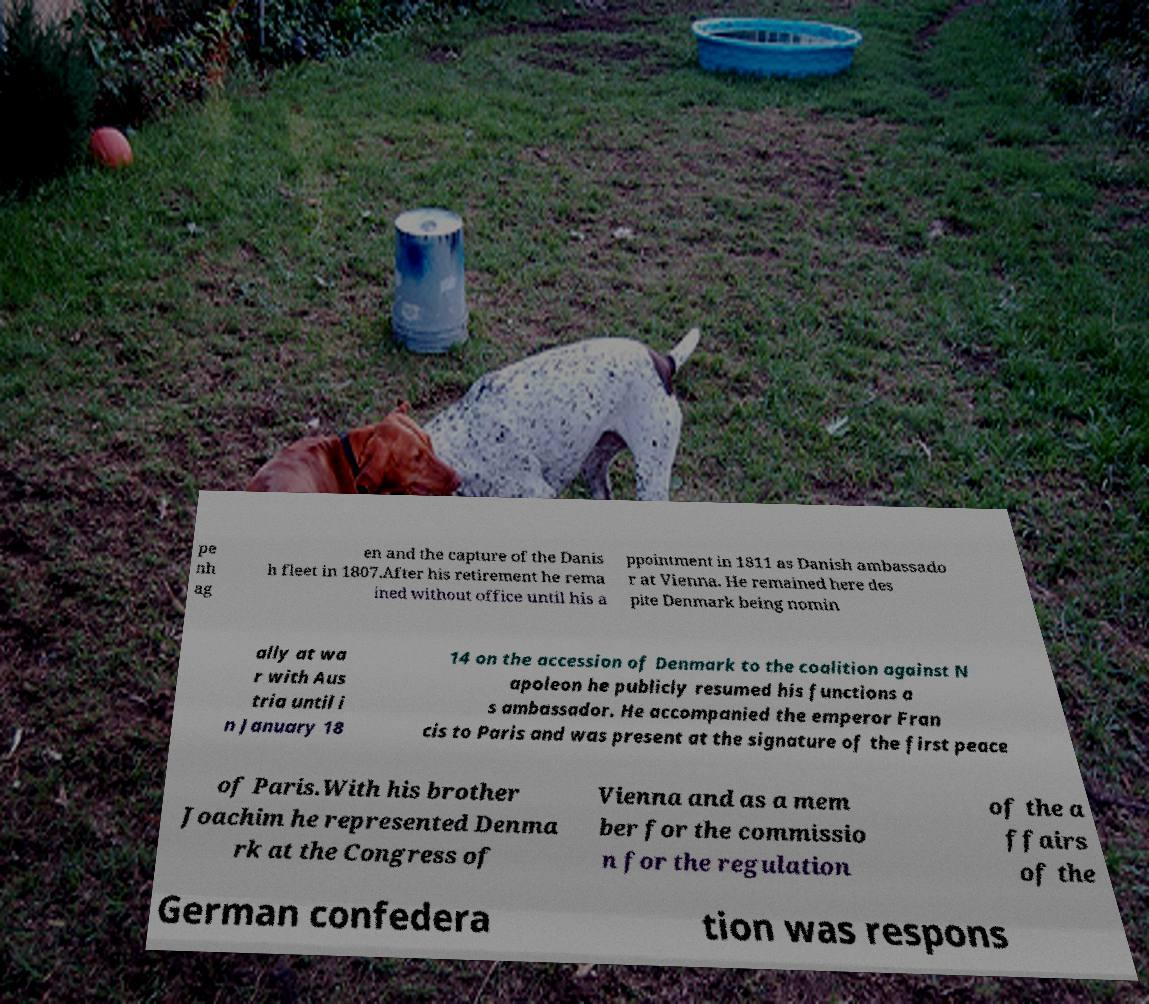I need the written content from this picture converted into text. Can you do that? pe nh ag en and the capture of the Danis h fleet in 1807.After his retirement he rema ined without office until his a ppointment in 1811 as Danish ambassado r at Vienna. He remained here des pite Denmark being nomin ally at wa r with Aus tria until i n January 18 14 on the accession of Denmark to the coalition against N apoleon he publicly resumed his functions a s ambassador. He accompanied the emperor Fran cis to Paris and was present at the signature of the first peace of Paris.With his brother Joachim he represented Denma rk at the Congress of Vienna and as a mem ber for the commissio n for the regulation of the a ffairs of the German confedera tion was respons 